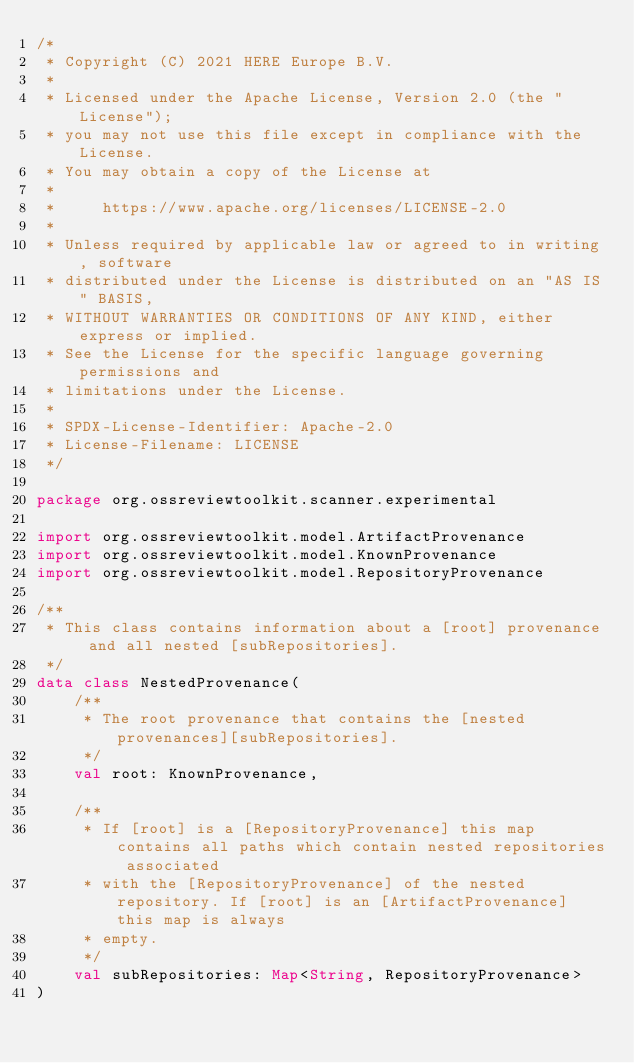<code> <loc_0><loc_0><loc_500><loc_500><_Kotlin_>/*
 * Copyright (C) 2021 HERE Europe B.V.
 *
 * Licensed under the Apache License, Version 2.0 (the "License");
 * you may not use this file except in compliance with the License.
 * You may obtain a copy of the License at
 *
 *     https://www.apache.org/licenses/LICENSE-2.0
 *
 * Unless required by applicable law or agreed to in writing, software
 * distributed under the License is distributed on an "AS IS" BASIS,
 * WITHOUT WARRANTIES OR CONDITIONS OF ANY KIND, either express or implied.
 * See the License for the specific language governing permissions and
 * limitations under the License.
 *
 * SPDX-License-Identifier: Apache-2.0
 * License-Filename: LICENSE
 */

package org.ossreviewtoolkit.scanner.experimental

import org.ossreviewtoolkit.model.ArtifactProvenance
import org.ossreviewtoolkit.model.KnownProvenance
import org.ossreviewtoolkit.model.RepositoryProvenance

/**
 * This class contains information about a [root] provenance and all nested [subRepositories].
 */
data class NestedProvenance(
    /**
     * The root provenance that contains the [nested provenances][subRepositories].
     */
    val root: KnownProvenance,

    /**
     * If [root] is a [RepositoryProvenance] this map contains all paths which contain nested repositories associated
     * with the [RepositoryProvenance] of the nested repository. If [root] is an [ArtifactProvenance] this map is always
     * empty.
     */
    val subRepositories: Map<String, RepositoryProvenance>
)
</code> 